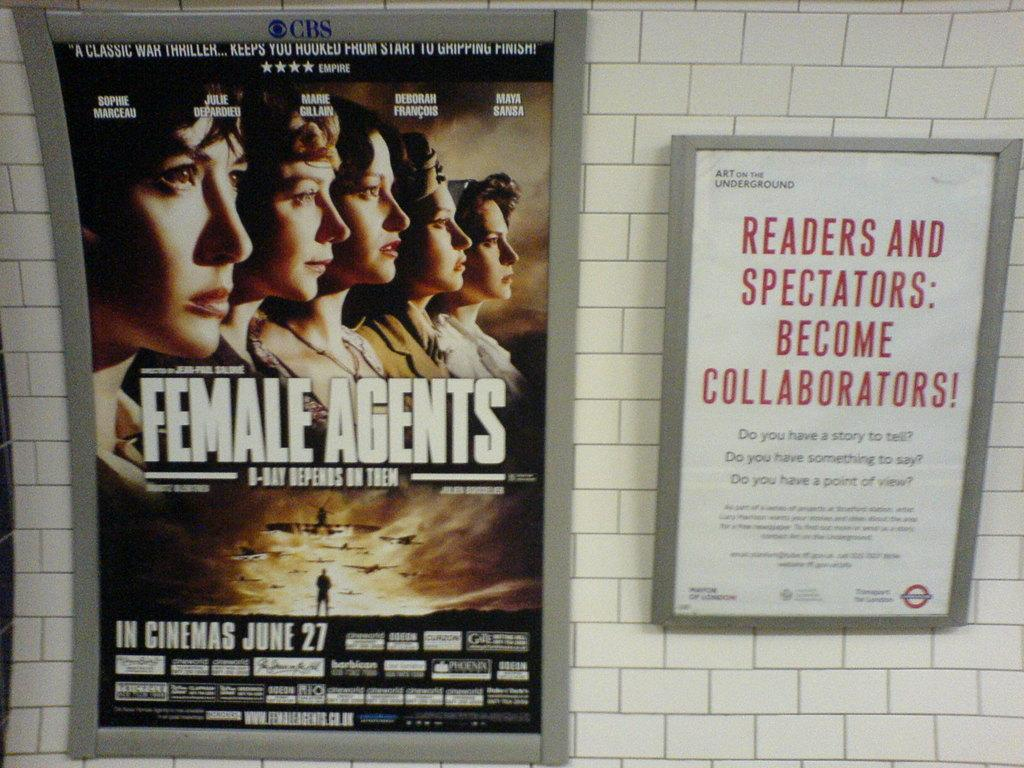<image>
Describe the image concisely. two posters with the left one showing movie Female Agents 